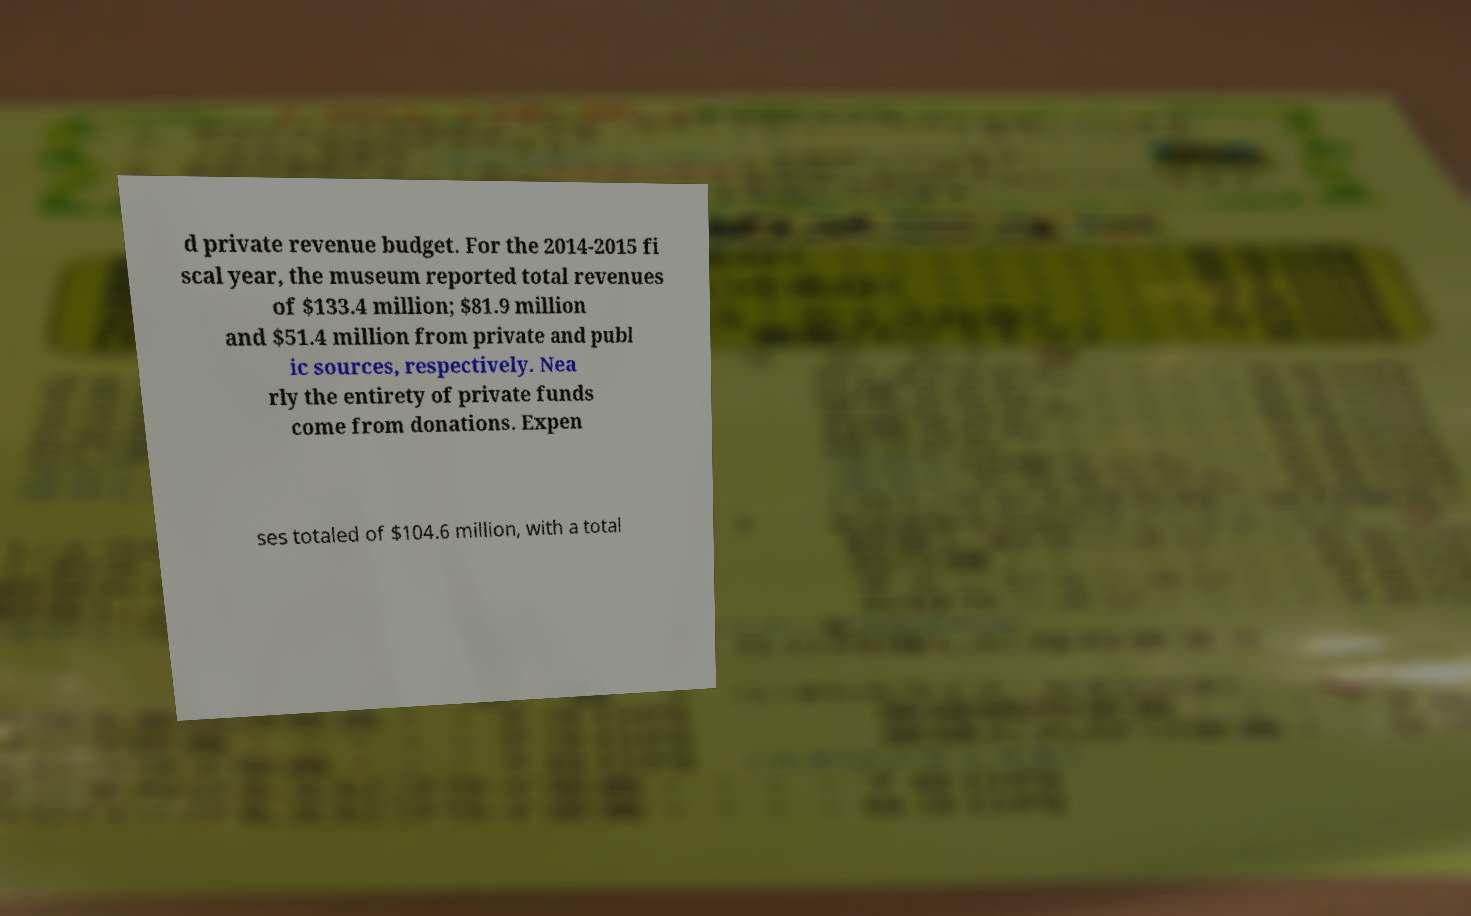Can you read and provide the text displayed in the image?This photo seems to have some interesting text. Can you extract and type it out for me? d private revenue budget. For the 2014-2015 fi scal year, the museum reported total revenues of $133.4 million; $81.9 million and $51.4 million from private and publ ic sources, respectively. Nea rly the entirety of private funds come from donations. Expen ses totaled of $104.6 million, with a total 